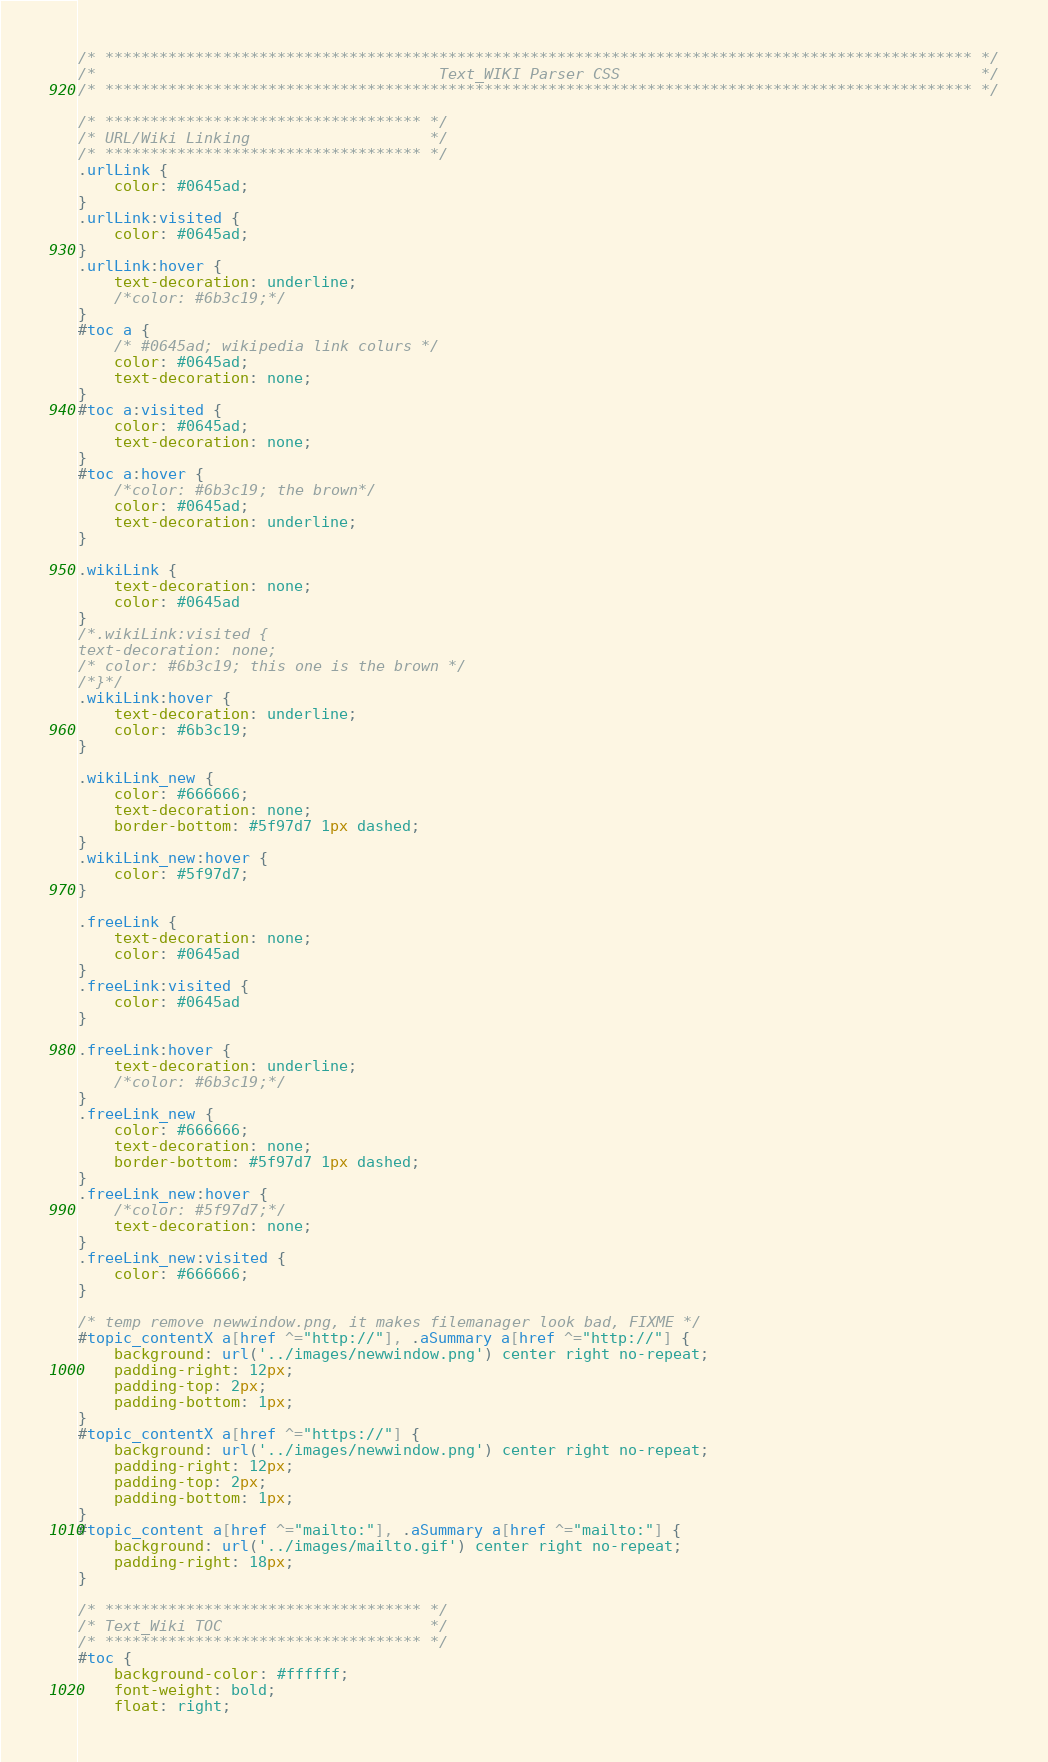Convert code to text. <code><loc_0><loc_0><loc_500><loc_500><_CSS_>/* ************************************************************************************************ */
/*                                      Text_WIKI Parser CSS                                        */
/* ************************************************************************************************ */

/* *********************************** */
/* URL/Wiki Linking                    */
/* *********************************** */
.urlLink {
	color: #0645ad;
}
.urlLink:visited {
	color: #0645ad;
}
.urlLink:hover {
	text-decoration: underline;
	/*color: #6b3c19;*/
}
#toc a {
	/* #0645ad; wikipedia link colurs */
	color: #0645ad;
	text-decoration: none;	
}
#toc a:visited {
	color: #0645ad;
	text-decoration: none;
}
#toc a:hover {
	/*color: #6b3c19; the brown*/
	color: #0645ad;
	text-decoration: underline;
}

.wikiLink {
	text-decoration: none;
	color: #0645ad
}
/*.wikiLink:visited {
text-decoration: none;
/* color: #6b3c19; this one is the brown */
/*}*/
.wikiLink:hover {
	text-decoration: underline;
	color: #6b3c19;
}

.wikiLink_new {
	color: #666666;
	text-decoration: none;
	border-bottom: #5f97d7 1px dashed;
}
.wikiLink_new:hover {
	color: #5f97d7;
}

.freeLink {
	text-decoration: none;
	color: #0645ad
}
.freeLink:visited {
	color: #0645ad
}

.freeLink:hover {
	text-decoration: underline;
	/*color: #6b3c19;*/
}
.freeLink_new {
	color: #666666;
	text-decoration: none;
	border-bottom: #5f97d7 1px dashed;
}
.freeLink_new:hover {
	/*color: #5f97d7;*/
	text-decoration: none;
}
.freeLink_new:visited {
	color: #666666;
}

/* temp remove newwindow.png, it makes filemanager look bad, FIXME */
#topic_contentX a[href ^="http://"], .aSummary a[href ^="http://"] {
	background: url('../images/newwindow.png') center right no-repeat;
	padding-right: 12px;
	padding-top: 2px;
	padding-bottom: 1px;
}
#topic_contentX a[href ^="https://"] {
	background: url('../images/newwindow.png') center right no-repeat;
	padding-right: 12px;
	padding-top: 2px;
	padding-bottom: 1px;
}
#topic_content a[href ^="mailto:"], .aSummary a[href ^="mailto:"] {
	background: url('../images/mailto.gif') center right no-repeat;
	padding-right: 18px;
}

/* *********************************** */
/* Text_Wiki TOC                       */
/* *********************************** */
#toc {
	background-color: #ffffff;
	font-weight: bold;
	float: right;</code> 